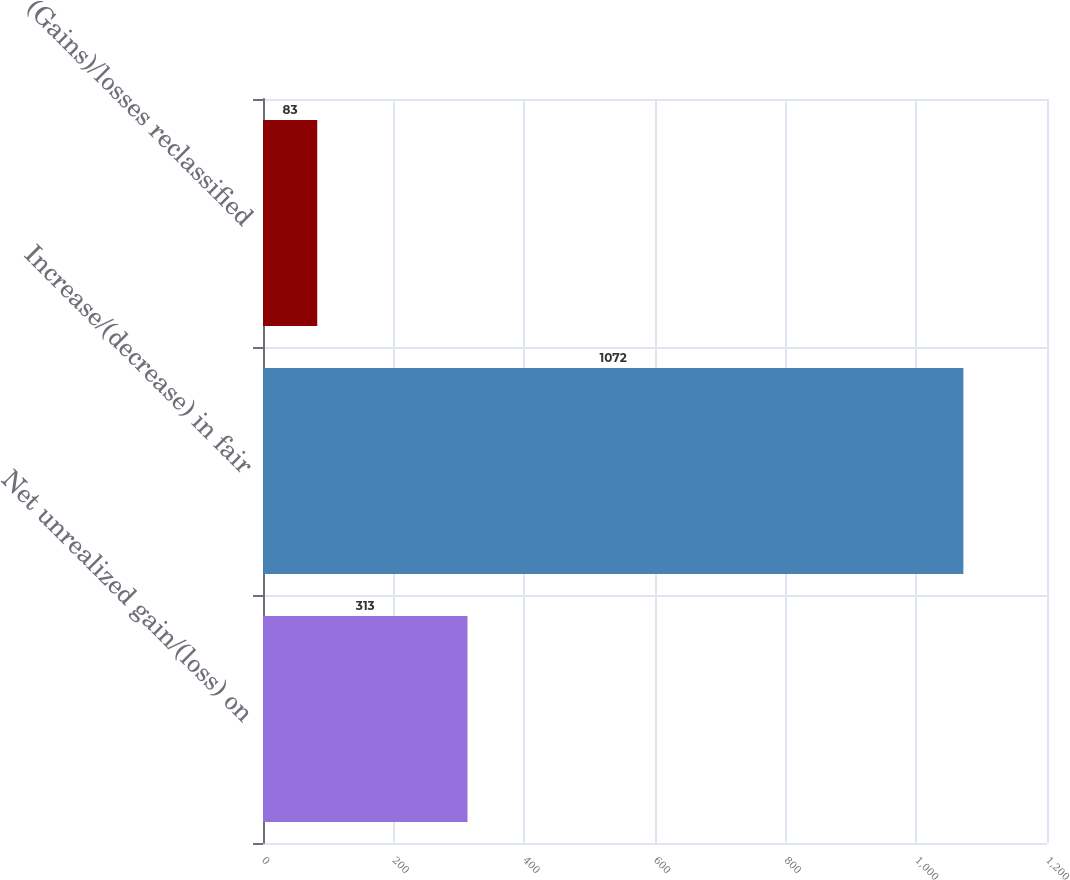<chart> <loc_0><loc_0><loc_500><loc_500><bar_chart><fcel>Net unrealized gain/(loss) on<fcel>Increase/(decrease) in fair<fcel>(Gains)/losses reclassified<nl><fcel>313<fcel>1072<fcel>83<nl></chart> 